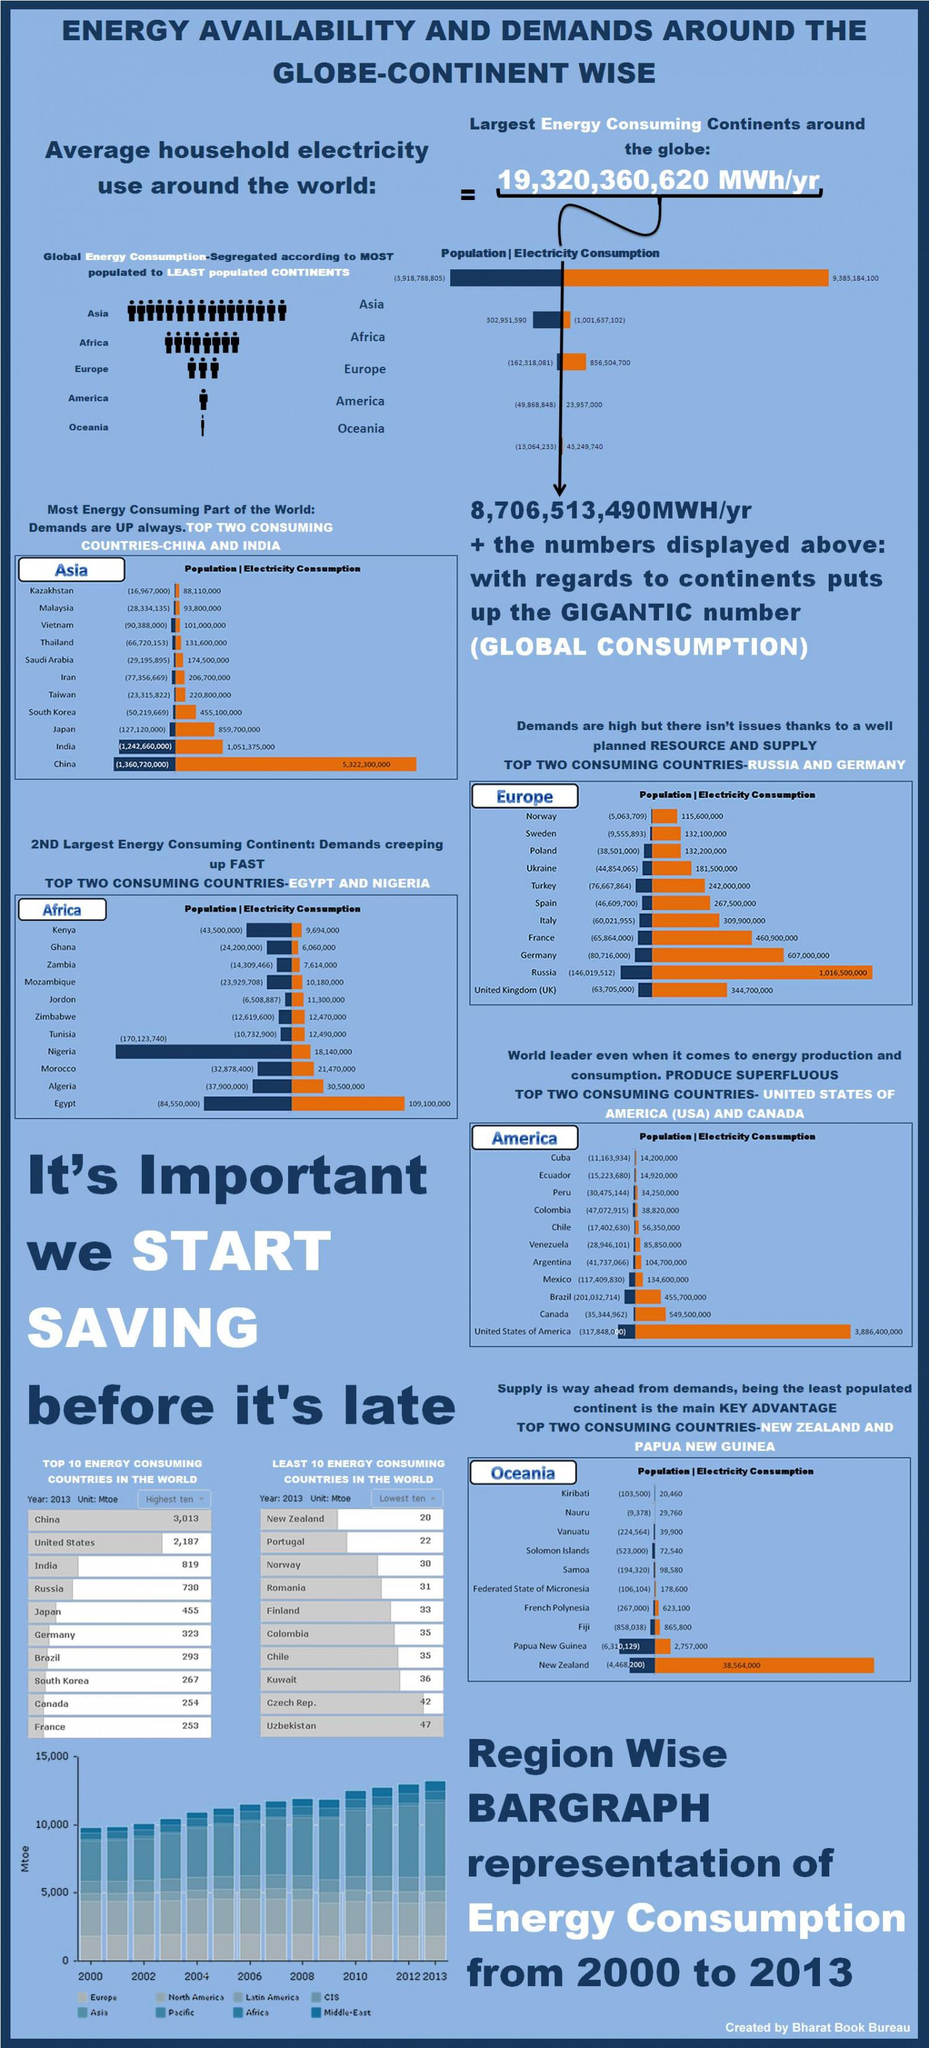Draw attention to some important aspects in this diagram. The United States is the highest consumer of electricity among the countries mentioned, Russia, China, and the United States. According to statistics, Asia is the largest consumer of energy and has shown a trend of increasing energy consumption from 2010 onwards. The population of Canada is approximately 35,344,962. Canada is the country with the second lowest energy consumption among the top 10 energy-consuming countries. The electricity consumption in France is approximately 460,900,000 megawatt-hours per year. 